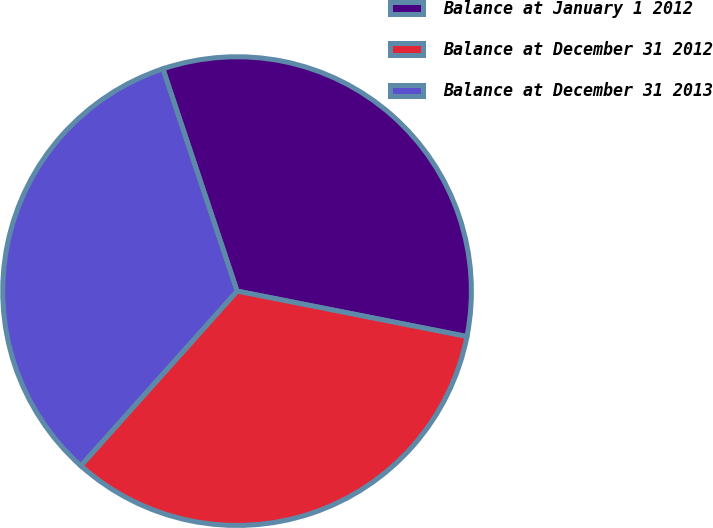Convert chart. <chart><loc_0><loc_0><loc_500><loc_500><pie_chart><fcel>Balance at January 1 2012<fcel>Balance at December 31 2012<fcel>Balance at December 31 2013<nl><fcel>33.23%<fcel>33.51%<fcel>33.26%<nl></chart> 